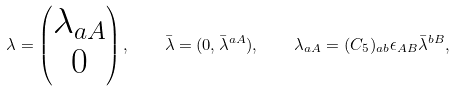<formula> <loc_0><loc_0><loc_500><loc_500>\lambda = \begin{pmatrix} \lambda _ { a A } \\ 0 \end{pmatrix} , \quad \bar { \lambda } = ( 0 , \bar { \lambda } ^ { a A } ) , \quad \lambda _ { a A } = ( C _ { 5 } ) _ { a b } \epsilon _ { A B } \bar { \lambda } ^ { b B } ,</formula> 